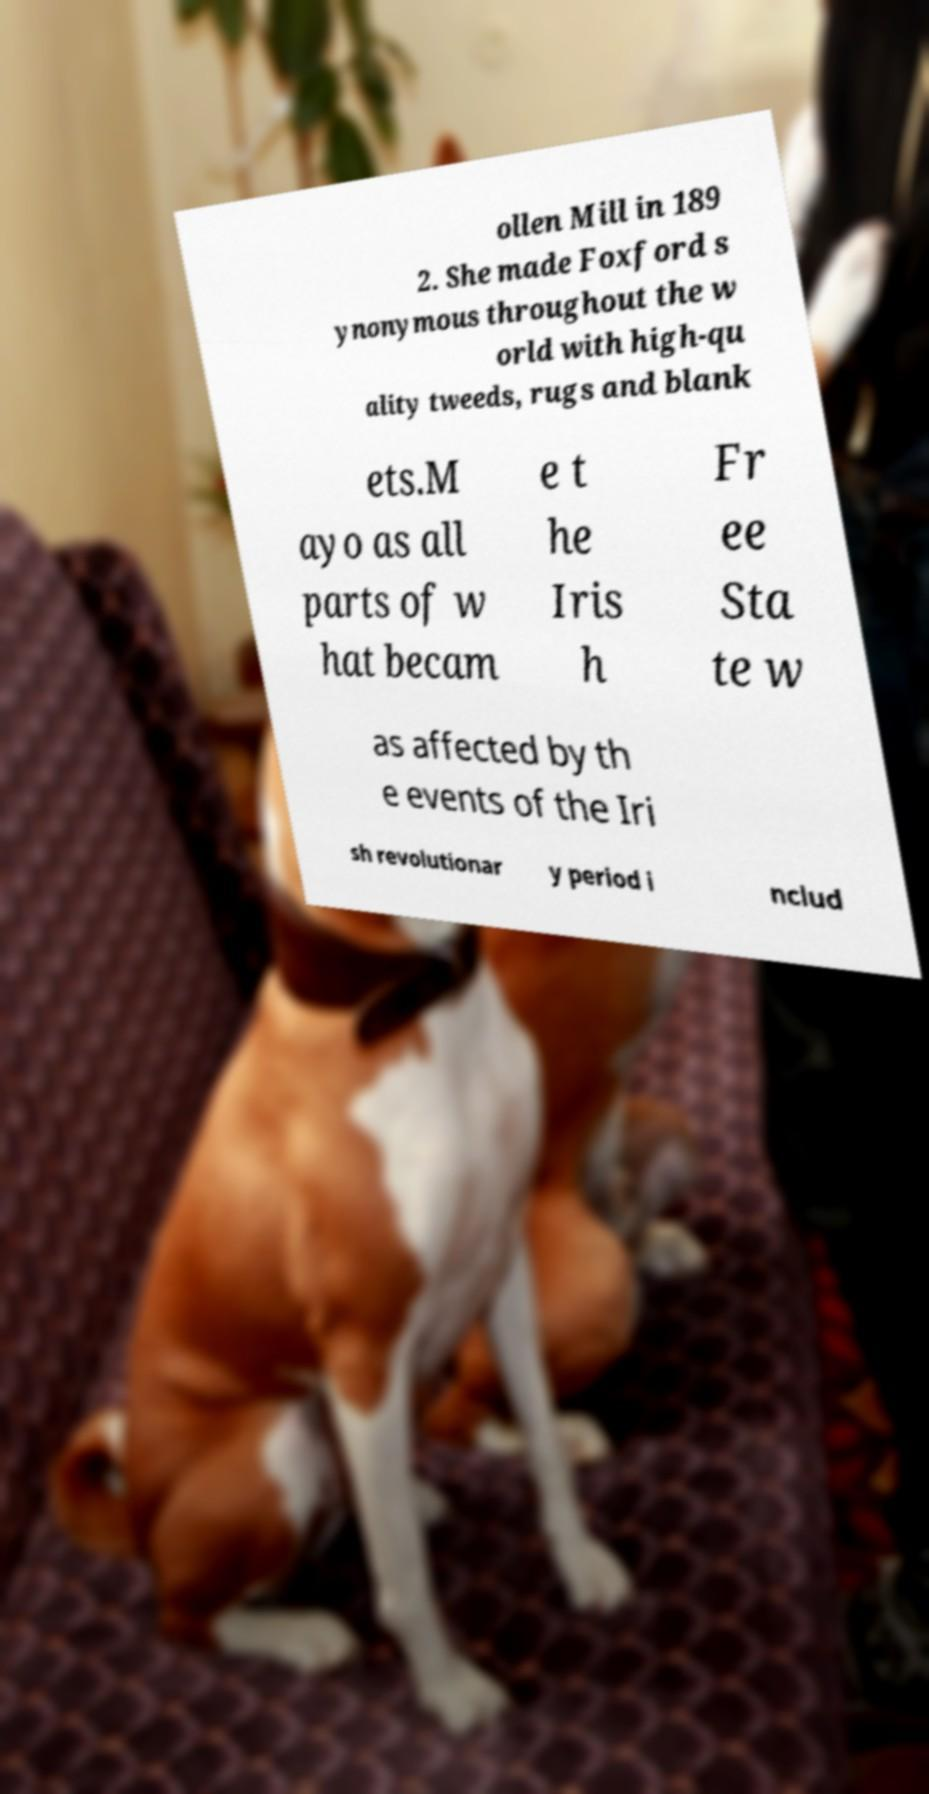Can you accurately transcribe the text from the provided image for me? ollen Mill in 189 2. She made Foxford s ynonymous throughout the w orld with high-qu ality tweeds, rugs and blank ets.M ayo as all parts of w hat becam e t he Iris h Fr ee Sta te w as affected by th e events of the Iri sh revolutionar y period i nclud 